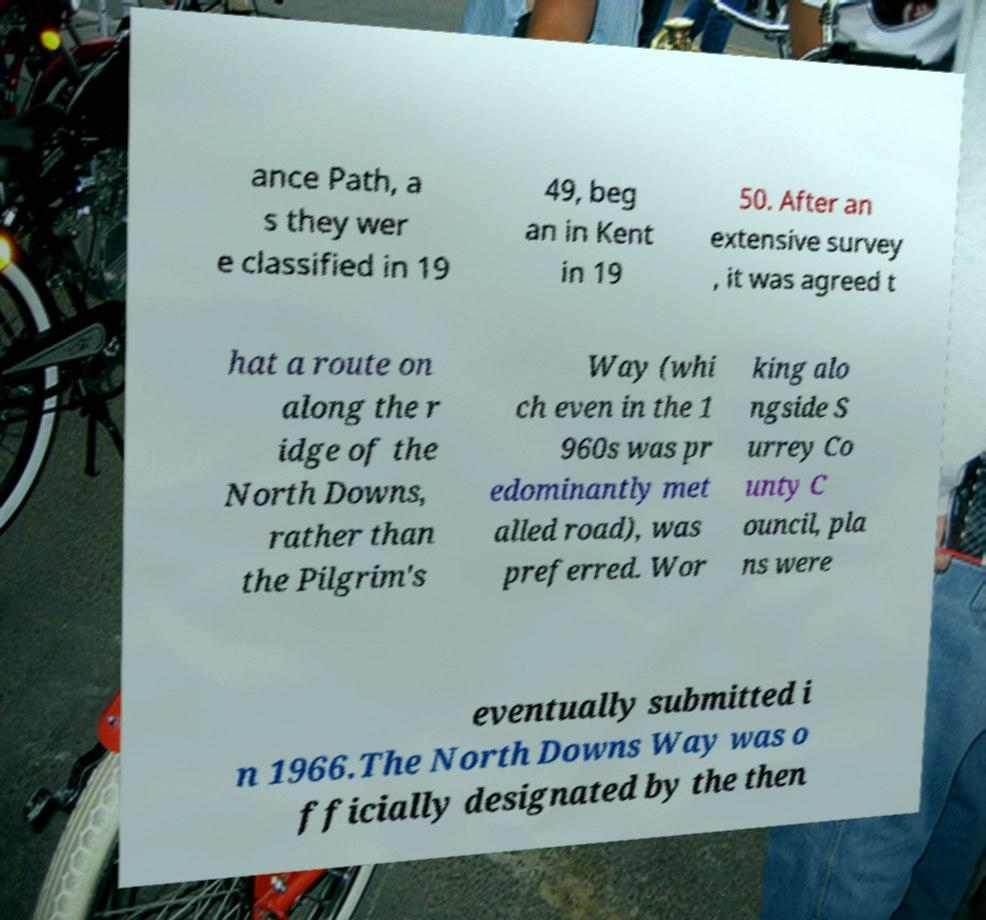Please identify and transcribe the text found in this image. ance Path, a s they wer e classified in 19 49, beg an in Kent in 19 50. After an extensive survey , it was agreed t hat a route on along the r idge of the North Downs, rather than the Pilgrim's Way (whi ch even in the 1 960s was pr edominantly met alled road), was preferred. Wor king alo ngside S urrey Co unty C ouncil, pla ns were eventually submitted i n 1966.The North Downs Way was o fficially designated by the then 